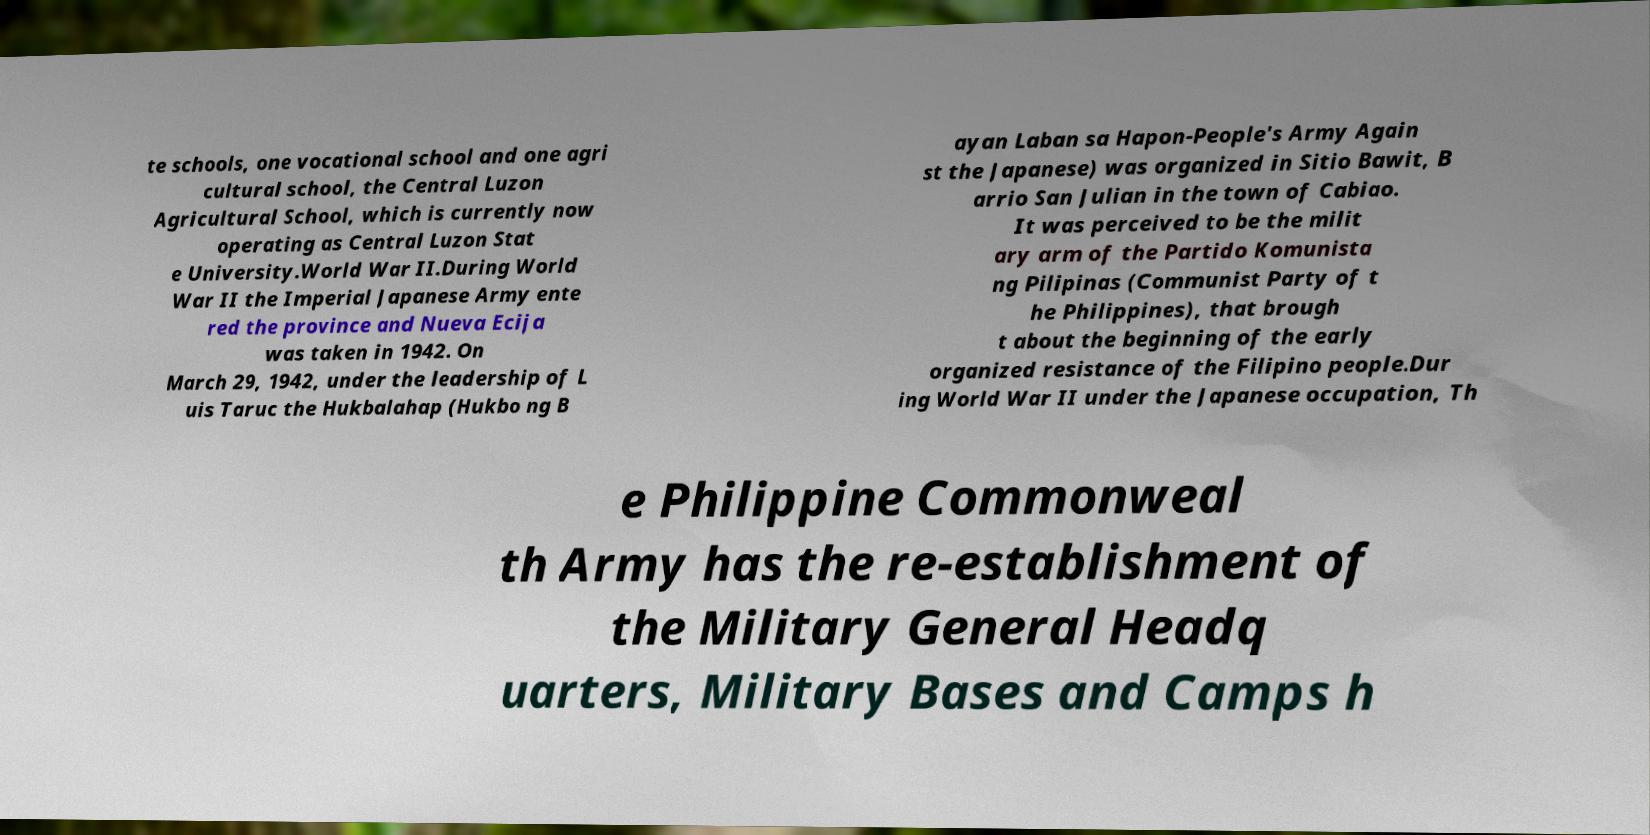Please identify and transcribe the text found in this image. te schools, one vocational school and one agri cultural school, the Central Luzon Agricultural School, which is currently now operating as Central Luzon Stat e University.World War II.During World War II the Imperial Japanese Army ente red the province and Nueva Ecija was taken in 1942. On March 29, 1942, under the leadership of L uis Taruc the Hukbalahap (Hukbo ng B ayan Laban sa Hapon-People's Army Again st the Japanese) was organized in Sitio Bawit, B arrio San Julian in the town of Cabiao. It was perceived to be the milit ary arm of the Partido Komunista ng Pilipinas (Communist Party of t he Philippines), that brough t about the beginning of the early organized resistance of the Filipino people.Dur ing World War II under the Japanese occupation, Th e Philippine Commonweal th Army has the re-establishment of the Military General Headq uarters, Military Bases and Camps h 